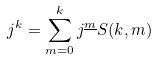<formula> <loc_0><loc_0><loc_500><loc_500>j ^ { k } = \sum _ { m = 0 } ^ { k } j ^ { \underline { m } } S ( k , m )</formula> 